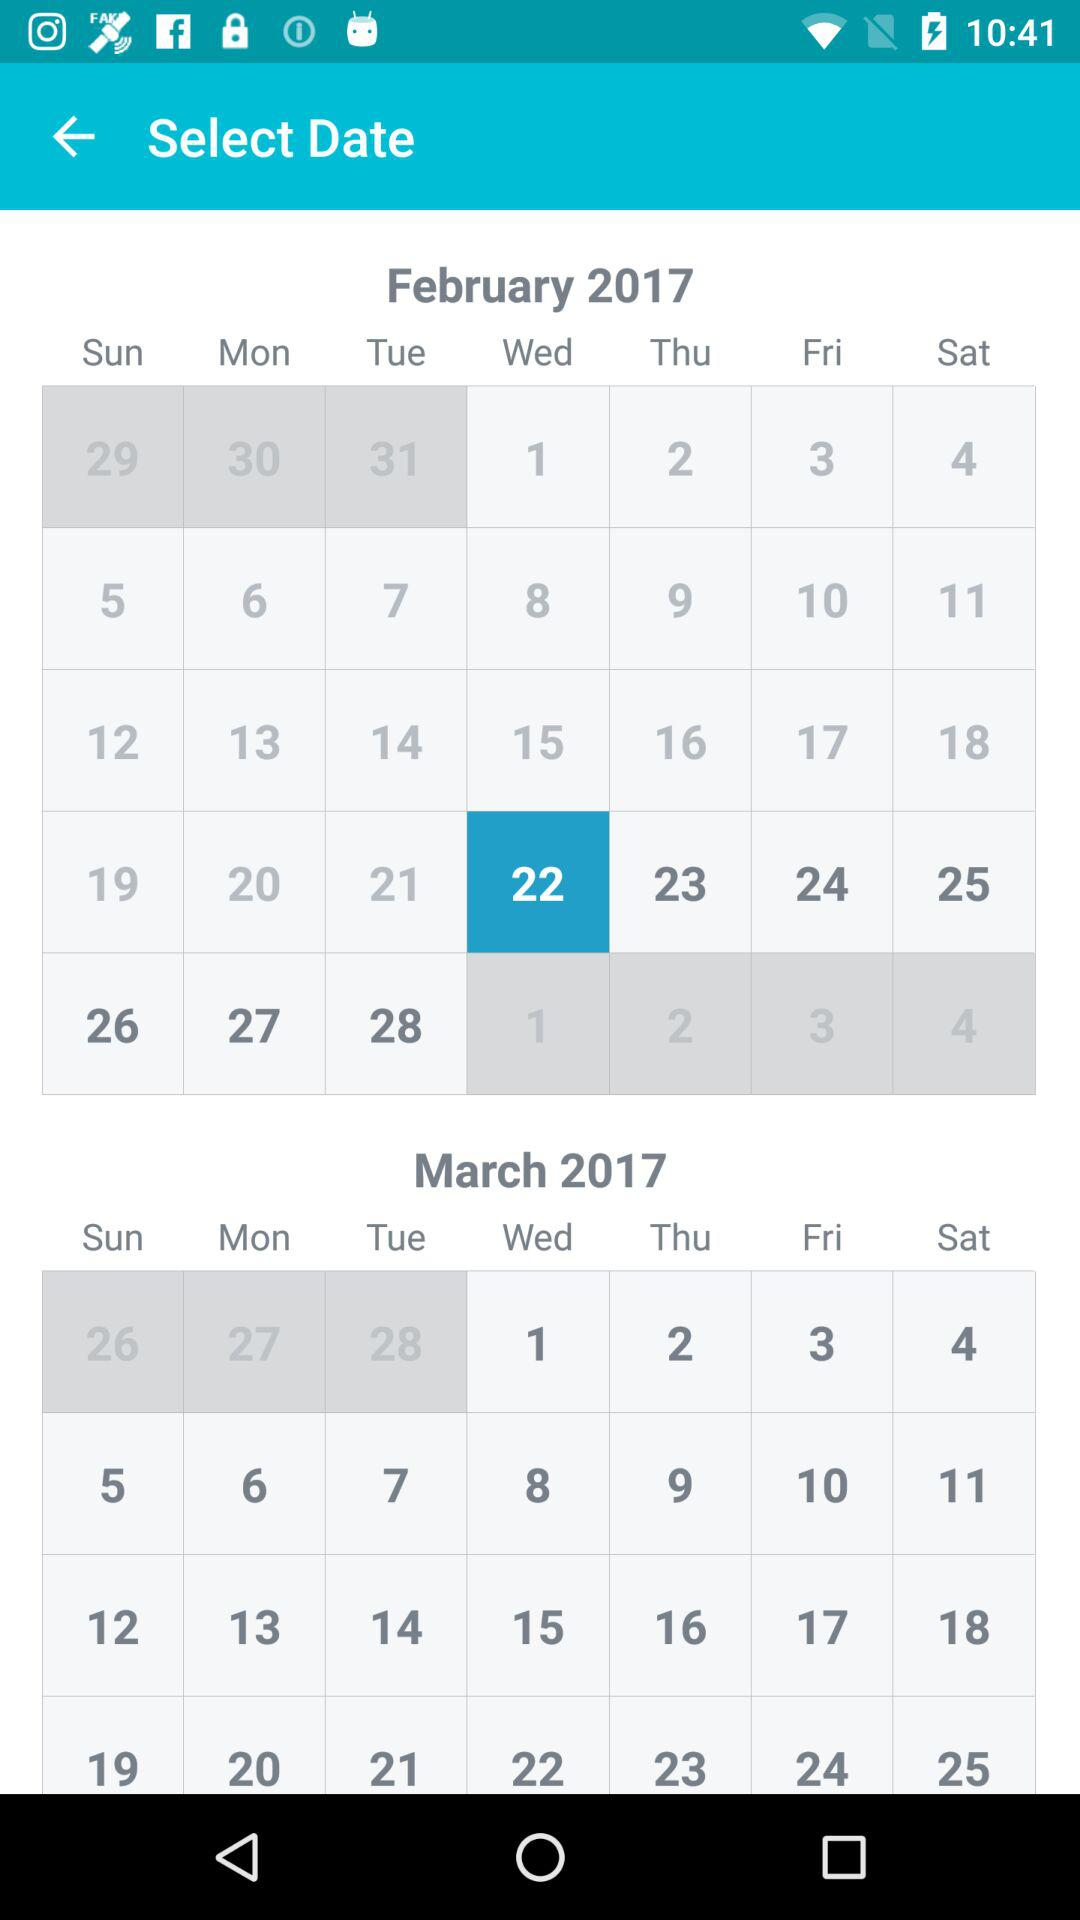What day is February 22, 2017? The day is Wednesday. 